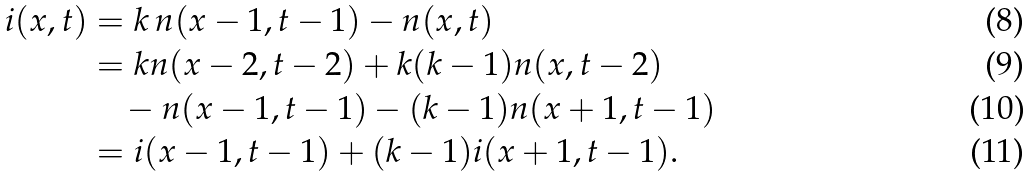<formula> <loc_0><loc_0><loc_500><loc_500>i ( x , t ) & = k \, n ( x - 1 , t - 1 ) - n ( x , t ) \\ & = k n ( x - 2 , t - 2 ) + k ( k - 1 ) n ( x , t - 2 ) \\ & \quad - n ( x - 1 , t - 1 ) - ( k - 1 ) n ( x + 1 , t - 1 ) \\ & = i ( x - 1 , t - 1 ) + ( k - 1 ) i ( x + 1 , t - 1 ) .</formula> 